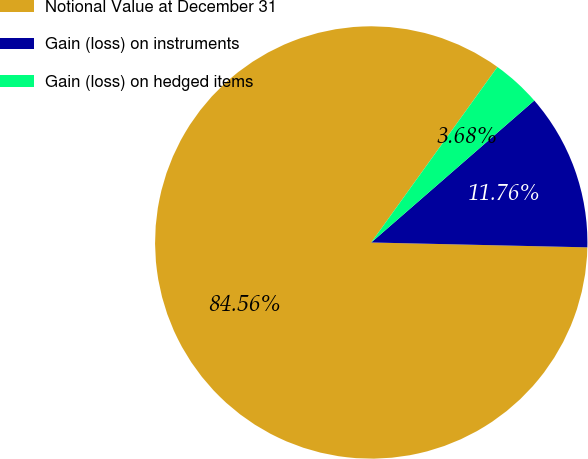<chart> <loc_0><loc_0><loc_500><loc_500><pie_chart><fcel>Notional Value at December 31<fcel>Gain (loss) on instruments<fcel>Gain (loss) on hedged items<nl><fcel>84.56%<fcel>11.76%<fcel>3.68%<nl></chart> 